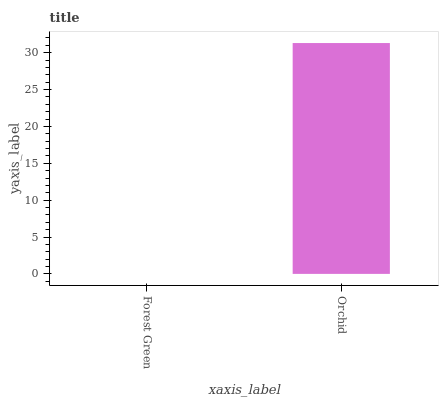Is Forest Green the minimum?
Answer yes or no. Yes. Is Orchid the maximum?
Answer yes or no. Yes. Is Orchid the minimum?
Answer yes or no. No. Is Orchid greater than Forest Green?
Answer yes or no. Yes. Is Forest Green less than Orchid?
Answer yes or no. Yes. Is Forest Green greater than Orchid?
Answer yes or no. No. Is Orchid less than Forest Green?
Answer yes or no. No. Is Orchid the high median?
Answer yes or no. Yes. Is Forest Green the low median?
Answer yes or no. Yes. Is Forest Green the high median?
Answer yes or no. No. Is Orchid the low median?
Answer yes or no. No. 